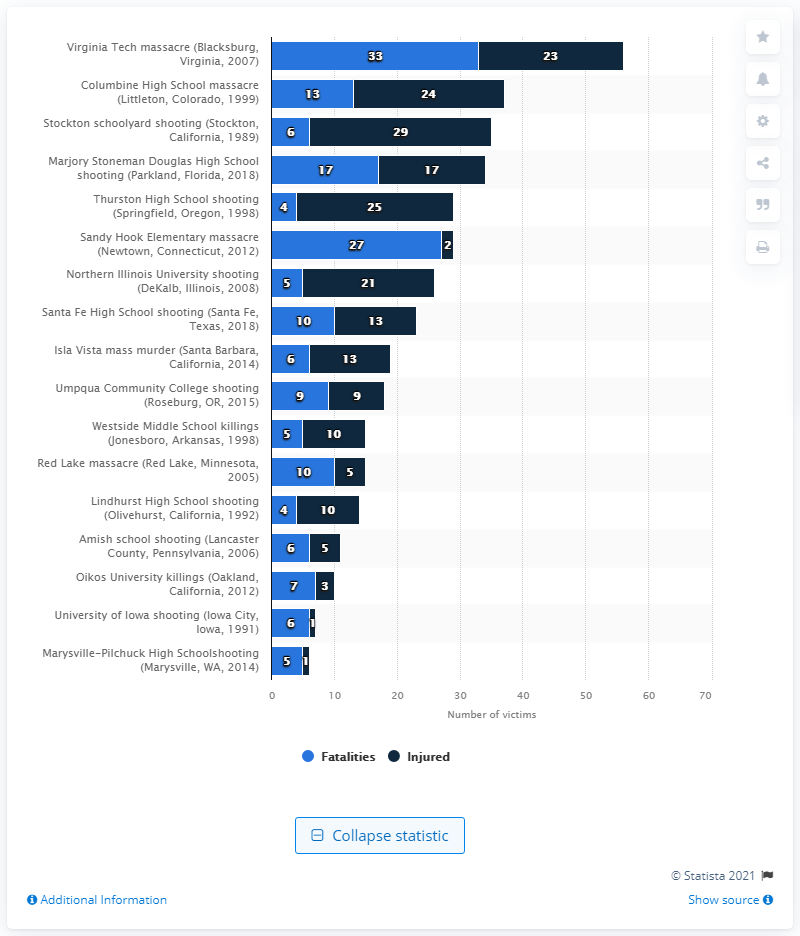Highlight a few significant elements in this photo. In the Virginia Tech school shooting, 23 people were injured. The Sandy Hook Elementary massacre resulted in the deaths of 27 people. Thirty-three individuals lost their lives in the Virginia Tech school shooting. 